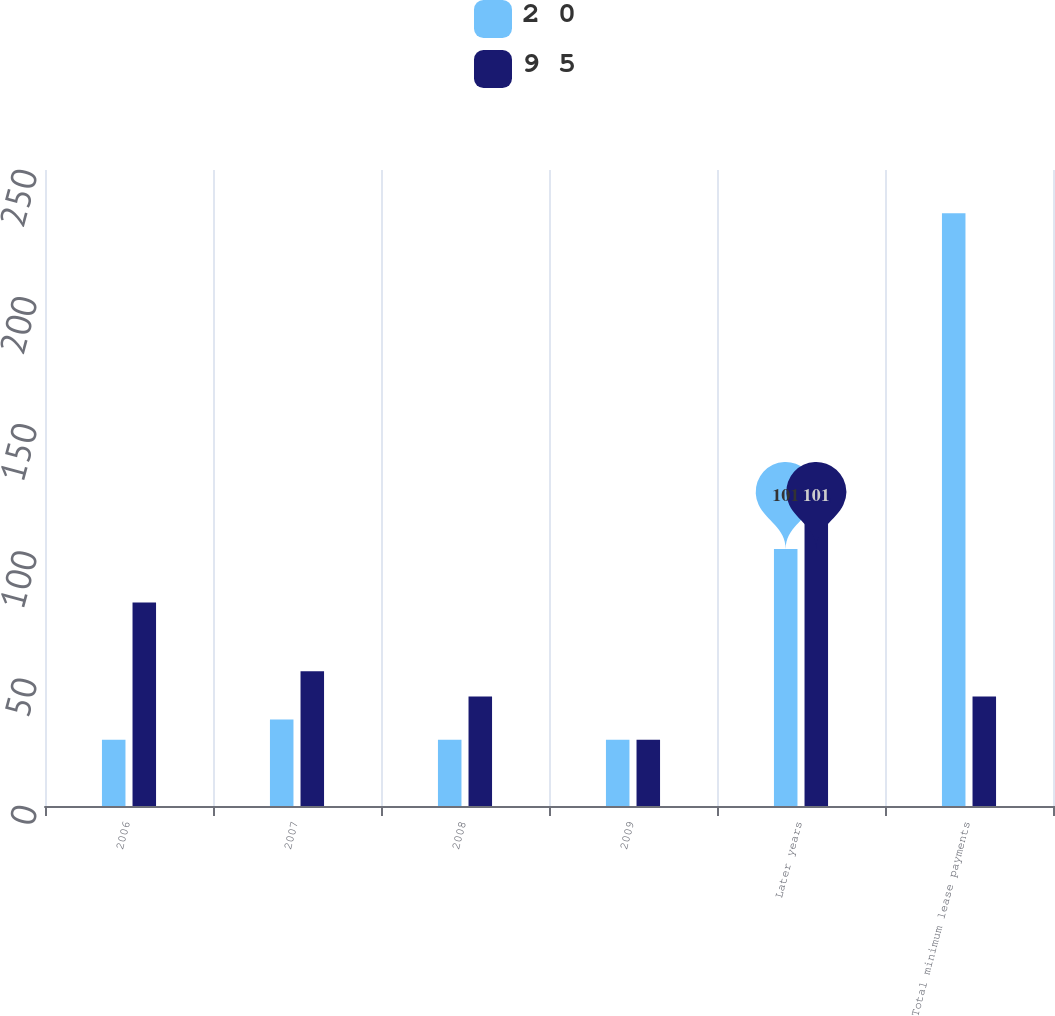<chart> <loc_0><loc_0><loc_500><loc_500><stacked_bar_chart><ecel><fcel>2006<fcel>2007<fcel>2008<fcel>2009<fcel>Later years<fcel>Total minimum lease payments<nl><fcel>2 0<fcel>26<fcel>34<fcel>26<fcel>26<fcel>101<fcel>233<nl><fcel>9 5<fcel>80<fcel>53<fcel>43<fcel>26<fcel>120<fcel>43<nl></chart> 